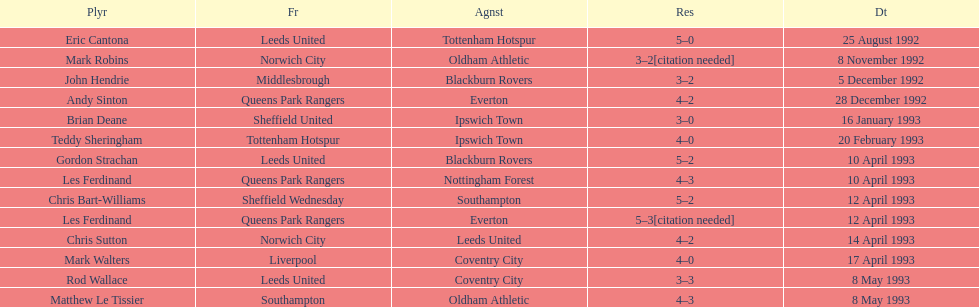In the 1992-1993 premier league, what was the total number of hat tricks scored by all players? 14. 